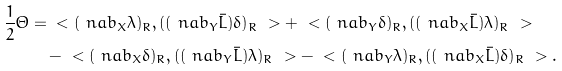Convert formula to latex. <formula><loc_0><loc_0><loc_500><loc_500>\frac { 1 } { 2 } \Theta = & \ < ( \ n a b _ { X } \lambda ) _ { R } , ( ( \ n a b _ { Y } \bar { L } ) \delta ) _ { R } \ > + \ < ( \ n a b _ { Y } \delta ) _ { R } , ( ( \ n a b _ { X } \bar { L } ) \lambda ) _ { R } \ > \\ & \, - \ < ( \ n a b _ { X } \delta ) _ { R } , ( ( \ n a b _ { Y } \bar { L } ) \lambda ) _ { R } \ > - \ < ( \ n a b _ { Y } \lambda ) _ { R } , ( ( \ n a b _ { X } \bar { L } ) \delta ) _ { R } \ > .</formula> 